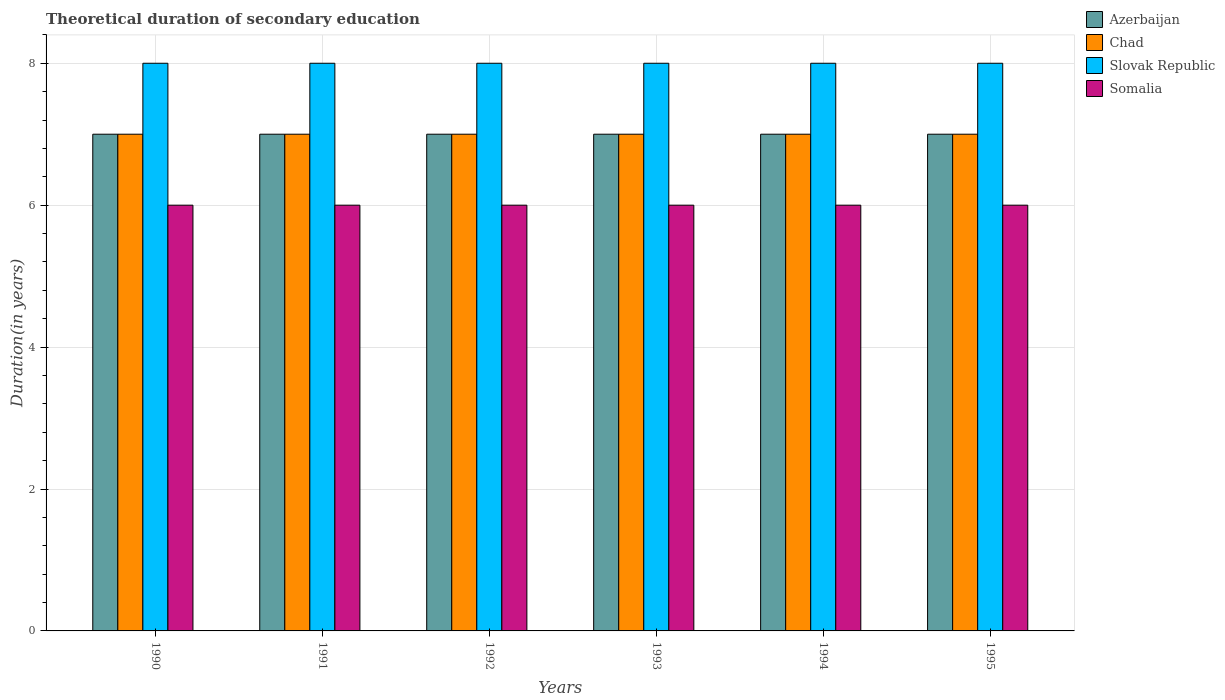Are the number of bars per tick equal to the number of legend labels?
Make the answer very short. Yes. How many bars are there on the 6th tick from the right?
Provide a succinct answer. 4. What is the label of the 1st group of bars from the left?
Your answer should be compact. 1990. In how many cases, is the number of bars for a given year not equal to the number of legend labels?
Offer a very short reply. 0. What is the total theoretical duration of secondary education in Azerbaijan in 1994?
Give a very brief answer. 7. Across all years, what is the minimum total theoretical duration of secondary education in Somalia?
Keep it short and to the point. 6. In which year was the total theoretical duration of secondary education in Somalia minimum?
Give a very brief answer. 1990. What is the total total theoretical duration of secondary education in Azerbaijan in the graph?
Keep it short and to the point. 42. What is the difference between the total theoretical duration of secondary education in Chad in 1993 and the total theoretical duration of secondary education in Slovak Republic in 1995?
Offer a very short reply. -1. In the year 1992, what is the difference between the total theoretical duration of secondary education in Slovak Republic and total theoretical duration of secondary education in Azerbaijan?
Your answer should be compact. 1. What is the ratio of the total theoretical duration of secondary education in Somalia in 1990 to that in 1994?
Keep it short and to the point. 1. What is the difference between the highest and the second highest total theoretical duration of secondary education in Chad?
Offer a very short reply. 0. In how many years, is the total theoretical duration of secondary education in Slovak Republic greater than the average total theoretical duration of secondary education in Slovak Republic taken over all years?
Keep it short and to the point. 0. Is it the case that in every year, the sum of the total theoretical duration of secondary education in Azerbaijan and total theoretical duration of secondary education in Somalia is greater than the sum of total theoretical duration of secondary education in Chad and total theoretical duration of secondary education in Slovak Republic?
Your answer should be very brief. No. What does the 4th bar from the left in 1995 represents?
Your answer should be very brief. Somalia. What does the 2nd bar from the right in 1995 represents?
Give a very brief answer. Slovak Republic. How many bars are there?
Keep it short and to the point. 24. What is the difference between two consecutive major ticks on the Y-axis?
Your response must be concise. 2. Does the graph contain grids?
Provide a short and direct response. Yes. How are the legend labels stacked?
Offer a terse response. Vertical. What is the title of the graph?
Your response must be concise. Theoretical duration of secondary education. Does "Virgin Islands" appear as one of the legend labels in the graph?
Ensure brevity in your answer.  No. What is the label or title of the X-axis?
Provide a short and direct response. Years. What is the label or title of the Y-axis?
Give a very brief answer. Duration(in years). What is the Duration(in years) of Chad in 1990?
Give a very brief answer. 7. What is the Duration(in years) of Somalia in 1990?
Offer a very short reply. 6. What is the Duration(in years) of Slovak Republic in 1991?
Your response must be concise. 8. What is the Duration(in years) in Somalia in 1991?
Provide a succinct answer. 6. What is the Duration(in years) of Slovak Republic in 1992?
Provide a succinct answer. 8. What is the Duration(in years) of Somalia in 1992?
Your answer should be compact. 6. What is the Duration(in years) in Azerbaijan in 1993?
Ensure brevity in your answer.  7. What is the Duration(in years) of Slovak Republic in 1993?
Ensure brevity in your answer.  8. What is the Duration(in years) in Somalia in 1993?
Your answer should be very brief. 6. What is the Duration(in years) in Chad in 1994?
Ensure brevity in your answer.  7. What is the Duration(in years) in Slovak Republic in 1994?
Make the answer very short. 8. What is the Duration(in years) of Somalia in 1994?
Make the answer very short. 6. Across all years, what is the maximum Duration(in years) in Slovak Republic?
Provide a short and direct response. 8. Across all years, what is the maximum Duration(in years) of Somalia?
Provide a short and direct response. 6. What is the total Duration(in years) in Azerbaijan in the graph?
Your response must be concise. 42. What is the total Duration(in years) in Chad in the graph?
Provide a succinct answer. 42. What is the total Duration(in years) of Somalia in the graph?
Provide a succinct answer. 36. What is the difference between the Duration(in years) of Azerbaijan in 1990 and that in 1991?
Your answer should be very brief. 0. What is the difference between the Duration(in years) of Chad in 1990 and that in 1991?
Ensure brevity in your answer.  0. What is the difference between the Duration(in years) of Slovak Republic in 1990 and that in 1991?
Ensure brevity in your answer.  0. What is the difference between the Duration(in years) in Azerbaijan in 1990 and that in 1992?
Your response must be concise. 0. What is the difference between the Duration(in years) in Slovak Republic in 1990 and that in 1992?
Provide a short and direct response. 0. What is the difference between the Duration(in years) in Azerbaijan in 1990 and that in 1993?
Make the answer very short. 0. What is the difference between the Duration(in years) of Somalia in 1990 and that in 1993?
Give a very brief answer. 0. What is the difference between the Duration(in years) in Azerbaijan in 1990 and that in 1994?
Your answer should be very brief. 0. What is the difference between the Duration(in years) in Chad in 1990 and that in 1994?
Offer a terse response. 0. What is the difference between the Duration(in years) in Azerbaijan in 1990 and that in 1995?
Your response must be concise. 0. What is the difference between the Duration(in years) in Chad in 1990 and that in 1995?
Your answer should be very brief. 0. What is the difference between the Duration(in years) in Slovak Republic in 1990 and that in 1995?
Offer a terse response. 0. What is the difference between the Duration(in years) in Somalia in 1990 and that in 1995?
Keep it short and to the point. 0. What is the difference between the Duration(in years) of Azerbaijan in 1991 and that in 1992?
Give a very brief answer. 0. What is the difference between the Duration(in years) in Somalia in 1991 and that in 1992?
Your answer should be very brief. 0. What is the difference between the Duration(in years) of Chad in 1991 and that in 1993?
Provide a succinct answer. 0. What is the difference between the Duration(in years) of Slovak Republic in 1991 and that in 1993?
Provide a succinct answer. 0. What is the difference between the Duration(in years) of Chad in 1991 and that in 1994?
Your answer should be compact. 0. What is the difference between the Duration(in years) in Slovak Republic in 1991 and that in 1994?
Offer a terse response. 0. What is the difference between the Duration(in years) of Somalia in 1991 and that in 1994?
Your answer should be compact. 0. What is the difference between the Duration(in years) of Slovak Republic in 1991 and that in 1995?
Provide a succinct answer. 0. What is the difference between the Duration(in years) in Azerbaijan in 1992 and that in 1993?
Your response must be concise. 0. What is the difference between the Duration(in years) of Slovak Republic in 1992 and that in 1993?
Your response must be concise. 0. What is the difference between the Duration(in years) of Azerbaijan in 1992 and that in 1994?
Offer a very short reply. 0. What is the difference between the Duration(in years) in Chad in 1992 and that in 1994?
Provide a succinct answer. 0. What is the difference between the Duration(in years) in Chad in 1992 and that in 1995?
Offer a terse response. 0. What is the difference between the Duration(in years) of Slovak Republic in 1992 and that in 1995?
Give a very brief answer. 0. What is the difference between the Duration(in years) of Slovak Republic in 1993 and that in 1994?
Offer a terse response. 0. What is the difference between the Duration(in years) of Azerbaijan in 1994 and that in 1995?
Your answer should be very brief. 0. What is the difference between the Duration(in years) in Chad in 1994 and that in 1995?
Your response must be concise. 0. What is the difference between the Duration(in years) in Slovak Republic in 1994 and that in 1995?
Your response must be concise. 0. What is the difference between the Duration(in years) of Azerbaijan in 1990 and the Duration(in years) of Chad in 1991?
Make the answer very short. 0. What is the difference between the Duration(in years) in Chad in 1990 and the Duration(in years) in Slovak Republic in 1991?
Offer a terse response. -1. What is the difference between the Duration(in years) of Azerbaijan in 1990 and the Duration(in years) of Somalia in 1992?
Keep it short and to the point. 1. What is the difference between the Duration(in years) in Chad in 1990 and the Duration(in years) in Slovak Republic in 1992?
Keep it short and to the point. -1. What is the difference between the Duration(in years) in Slovak Republic in 1990 and the Duration(in years) in Somalia in 1992?
Offer a very short reply. 2. What is the difference between the Duration(in years) of Azerbaijan in 1990 and the Duration(in years) of Slovak Republic in 1993?
Provide a short and direct response. -1. What is the difference between the Duration(in years) in Azerbaijan in 1990 and the Duration(in years) in Somalia in 1993?
Ensure brevity in your answer.  1. What is the difference between the Duration(in years) in Chad in 1990 and the Duration(in years) in Slovak Republic in 1993?
Provide a short and direct response. -1. What is the difference between the Duration(in years) in Slovak Republic in 1990 and the Duration(in years) in Somalia in 1993?
Give a very brief answer. 2. What is the difference between the Duration(in years) in Azerbaijan in 1990 and the Duration(in years) in Chad in 1994?
Give a very brief answer. 0. What is the difference between the Duration(in years) in Azerbaijan in 1990 and the Duration(in years) in Slovak Republic in 1994?
Provide a succinct answer. -1. What is the difference between the Duration(in years) of Azerbaijan in 1990 and the Duration(in years) of Somalia in 1994?
Ensure brevity in your answer.  1. What is the difference between the Duration(in years) of Azerbaijan in 1990 and the Duration(in years) of Slovak Republic in 1995?
Your answer should be very brief. -1. What is the difference between the Duration(in years) of Chad in 1990 and the Duration(in years) of Somalia in 1995?
Your answer should be compact. 1. What is the difference between the Duration(in years) of Azerbaijan in 1991 and the Duration(in years) of Somalia in 1992?
Offer a very short reply. 1. What is the difference between the Duration(in years) of Chad in 1991 and the Duration(in years) of Slovak Republic in 1992?
Provide a succinct answer. -1. What is the difference between the Duration(in years) of Chad in 1991 and the Duration(in years) of Somalia in 1992?
Provide a short and direct response. 1. What is the difference between the Duration(in years) of Azerbaijan in 1991 and the Duration(in years) of Chad in 1993?
Your answer should be very brief. 0. What is the difference between the Duration(in years) in Azerbaijan in 1991 and the Duration(in years) in Somalia in 1993?
Keep it short and to the point. 1. What is the difference between the Duration(in years) in Chad in 1991 and the Duration(in years) in Slovak Republic in 1993?
Keep it short and to the point. -1. What is the difference between the Duration(in years) of Azerbaijan in 1991 and the Duration(in years) of Somalia in 1994?
Your answer should be very brief. 1. What is the difference between the Duration(in years) of Chad in 1991 and the Duration(in years) of Somalia in 1994?
Make the answer very short. 1. What is the difference between the Duration(in years) in Azerbaijan in 1991 and the Duration(in years) in Chad in 1995?
Give a very brief answer. 0. What is the difference between the Duration(in years) in Azerbaijan in 1991 and the Duration(in years) in Slovak Republic in 1995?
Your answer should be compact. -1. What is the difference between the Duration(in years) in Azerbaijan in 1991 and the Duration(in years) in Somalia in 1995?
Give a very brief answer. 1. What is the difference between the Duration(in years) in Chad in 1991 and the Duration(in years) in Somalia in 1995?
Offer a very short reply. 1. What is the difference between the Duration(in years) in Chad in 1992 and the Duration(in years) in Somalia in 1993?
Provide a short and direct response. 1. What is the difference between the Duration(in years) in Slovak Republic in 1992 and the Duration(in years) in Somalia in 1993?
Make the answer very short. 2. What is the difference between the Duration(in years) in Azerbaijan in 1992 and the Duration(in years) in Chad in 1994?
Make the answer very short. 0. What is the difference between the Duration(in years) of Chad in 1992 and the Duration(in years) of Somalia in 1994?
Make the answer very short. 1. What is the difference between the Duration(in years) in Slovak Republic in 1992 and the Duration(in years) in Somalia in 1994?
Keep it short and to the point. 2. What is the difference between the Duration(in years) in Azerbaijan in 1992 and the Duration(in years) in Slovak Republic in 1995?
Offer a terse response. -1. What is the difference between the Duration(in years) in Chad in 1992 and the Duration(in years) in Slovak Republic in 1995?
Provide a succinct answer. -1. What is the difference between the Duration(in years) in Slovak Republic in 1992 and the Duration(in years) in Somalia in 1995?
Ensure brevity in your answer.  2. What is the difference between the Duration(in years) of Azerbaijan in 1993 and the Duration(in years) of Chad in 1994?
Make the answer very short. 0. What is the difference between the Duration(in years) in Azerbaijan in 1993 and the Duration(in years) in Slovak Republic in 1994?
Provide a short and direct response. -1. What is the difference between the Duration(in years) of Azerbaijan in 1993 and the Duration(in years) of Somalia in 1994?
Provide a short and direct response. 1. What is the difference between the Duration(in years) of Slovak Republic in 1993 and the Duration(in years) of Somalia in 1994?
Keep it short and to the point. 2. What is the difference between the Duration(in years) of Chad in 1993 and the Duration(in years) of Slovak Republic in 1995?
Provide a succinct answer. -1. What is the difference between the Duration(in years) in Slovak Republic in 1993 and the Duration(in years) in Somalia in 1995?
Provide a succinct answer. 2. What is the difference between the Duration(in years) in Chad in 1994 and the Duration(in years) in Slovak Republic in 1995?
Ensure brevity in your answer.  -1. What is the difference between the Duration(in years) of Chad in 1994 and the Duration(in years) of Somalia in 1995?
Offer a very short reply. 1. What is the difference between the Duration(in years) in Slovak Republic in 1994 and the Duration(in years) in Somalia in 1995?
Offer a terse response. 2. What is the average Duration(in years) in Azerbaijan per year?
Keep it short and to the point. 7. What is the average Duration(in years) in Slovak Republic per year?
Offer a very short reply. 8. In the year 1990, what is the difference between the Duration(in years) of Azerbaijan and Duration(in years) of Slovak Republic?
Give a very brief answer. -1. In the year 1990, what is the difference between the Duration(in years) of Azerbaijan and Duration(in years) of Somalia?
Your answer should be compact. 1. In the year 1990, what is the difference between the Duration(in years) of Slovak Republic and Duration(in years) of Somalia?
Your answer should be very brief. 2. In the year 1991, what is the difference between the Duration(in years) in Azerbaijan and Duration(in years) in Chad?
Offer a very short reply. 0. In the year 1991, what is the difference between the Duration(in years) of Azerbaijan and Duration(in years) of Slovak Republic?
Your response must be concise. -1. In the year 1991, what is the difference between the Duration(in years) of Azerbaijan and Duration(in years) of Somalia?
Your response must be concise. 1. In the year 1991, what is the difference between the Duration(in years) in Chad and Duration(in years) in Somalia?
Keep it short and to the point. 1. In the year 1991, what is the difference between the Duration(in years) of Slovak Republic and Duration(in years) of Somalia?
Provide a short and direct response. 2. In the year 1992, what is the difference between the Duration(in years) in Azerbaijan and Duration(in years) in Slovak Republic?
Ensure brevity in your answer.  -1. In the year 1992, what is the difference between the Duration(in years) of Chad and Duration(in years) of Somalia?
Your answer should be compact. 1. In the year 1992, what is the difference between the Duration(in years) in Slovak Republic and Duration(in years) in Somalia?
Your response must be concise. 2. In the year 1993, what is the difference between the Duration(in years) of Azerbaijan and Duration(in years) of Slovak Republic?
Offer a very short reply. -1. In the year 1993, what is the difference between the Duration(in years) in Azerbaijan and Duration(in years) in Somalia?
Keep it short and to the point. 1. In the year 1993, what is the difference between the Duration(in years) of Chad and Duration(in years) of Somalia?
Your answer should be compact. 1. In the year 1994, what is the difference between the Duration(in years) of Azerbaijan and Duration(in years) of Chad?
Offer a very short reply. 0. In the year 1994, what is the difference between the Duration(in years) in Azerbaijan and Duration(in years) in Somalia?
Provide a short and direct response. 1. In the year 1994, what is the difference between the Duration(in years) in Slovak Republic and Duration(in years) in Somalia?
Your answer should be very brief. 2. In the year 1995, what is the difference between the Duration(in years) of Azerbaijan and Duration(in years) of Chad?
Ensure brevity in your answer.  0. In the year 1995, what is the difference between the Duration(in years) of Azerbaijan and Duration(in years) of Slovak Republic?
Your answer should be compact. -1. In the year 1995, what is the difference between the Duration(in years) in Azerbaijan and Duration(in years) in Somalia?
Provide a succinct answer. 1. In the year 1995, what is the difference between the Duration(in years) of Chad and Duration(in years) of Slovak Republic?
Give a very brief answer. -1. In the year 1995, what is the difference between the Duration(in years) of Slovak Republic and Duration(in years) of Somalia?
Your response must be concise. 2. What is the ratio of the Duration(in years) in Slovak Republic in 1990 to that in 1991?
Your response must be concise. 1. What is the ratio of the Duration(in years) of Slovak Republic in 1990 to that in 1992?
Offer a terse response. 1. What is the ratio of the Duration(in years) in Slovak Republic in 1990 to that in 1993?
Make the answer very short. 1. What is the ratio of the Duration(in years) in Somalia in 1990 to that in 1994?
Offer a terse response. 1. What is the ratio of the Duration(in years) in Chad in 1990 to that in 1995?
Offer a very short reply. 1. What is the ratio of the Duration(in years) in Azerbaijan in 1991 to that in 1992?
Your answer should be compact. 1. What is the ratio of the Duration(in years) of Chad in 1991 to that in 1992?
Your answer should be compact. 1. What is the ratio of the Duration(in years) of Slovak Republic in 1991 to that in 1992?
Give a very brief answer. 1. What is the ratio of the Duration(in years) of Somalia in 1991 to that in 1992?
Your answer should be very brief. 1. What is the ratio of the Duration(in years) of Azerbaijan in 1991 to that in 1993?
Your response must be concise. 1. What is the ratio of the Duration(in years) in Chad in 1991 to that in 1993?
Make the answer very short. 1. What is the ratio of the Duration(in years) of Slovak Republic in 1991 to that in 1993?
Keep it short and to the point. 1. What is the ratio of the Duration(in years) of Somalia in 1991 to that in 1993?
Your answer should be compact. 1. What is the ratio of the Duration(in years) in Azerbaijan in 1991 to that in 1994?
Your response must be concise. 1. What is the ratio of the Duration(in years) in Chad in 1991 to that in 1994?
Give a very brief answer. 1. What is the ratio of the Duration(in years) in Somalia in 1991 to that in 1994?
Keep it short and to the point. 1. What is the ratio of the Duration(in years) of Slovak Republic in 1991 to that in 1995?
Offer a terse response. 1. What is the ratio of the Duration(in years) in Chad in 1992 to that in 1994?
Keep it short and to the point. 1. What is the ratio of the Duration(in years) of Slovak Republic in 1992 to that in 1994?
Provide a short and direct response. 1. What is the ratio of the Duration(in years) in Somalia in 1992 to that in 1994?
Make the answer very short. 1. What is the ratio of the Duration(in years) in Chad in 1992 to that in 1995?
Offer a very short reply. 1. What is the ratio of the Duration(in years) in Slovak Republic in 1992 to that in 1995?
Ensure brevity in your answer.  1. What is the ratio of the Duration(in years) in Azerbaijan in 1993 to that in 1994?
Your answer should be very brief. 1. What is the ratio of the Duration(in years) in Somalia in 1993 to that in 1994?
Make the answer very short. 1. What is the ratio of the Duration(in years) in Azerbaijan in 1993 to that in 1995?
Ensure brevity in your answer.  1. What is the ratio of the Duration(in years) of Chad in 1993 to that in 1995?
Your response must be concise. 1. What is the ratio of the Duration(in years) in Slovak Republic in 1993 to that in 1995?
Give a very brief answer. 1. What is the ratio of the Duration(in years) of Slovak Republic in 1994 to that in 1995?
Offer a terse response. 1. What is the ratio of the Duration(in years) in Somalia in 1994 to that in 1995?
Provide a succinct answer. 1. What is the difference between the highest and the second highest Duration(in years) in Azerbaijan?
Make the answer very short. 0. What is the difference between the highest and the second highest Duration(in years) in Chad?
Offer a very short reply. 0. What is the difference between the highest and the lowest Duration(in years) of Azerbaijan?
Offer a terse response. 0. What is the difference between the highest and the lowest Duration(in years) in Chad?
Your answer should be very brief. 0. What is the difference between the highest and the lowest Duration(in years) in Slovak Republic?
Offer a terse response. 0. 